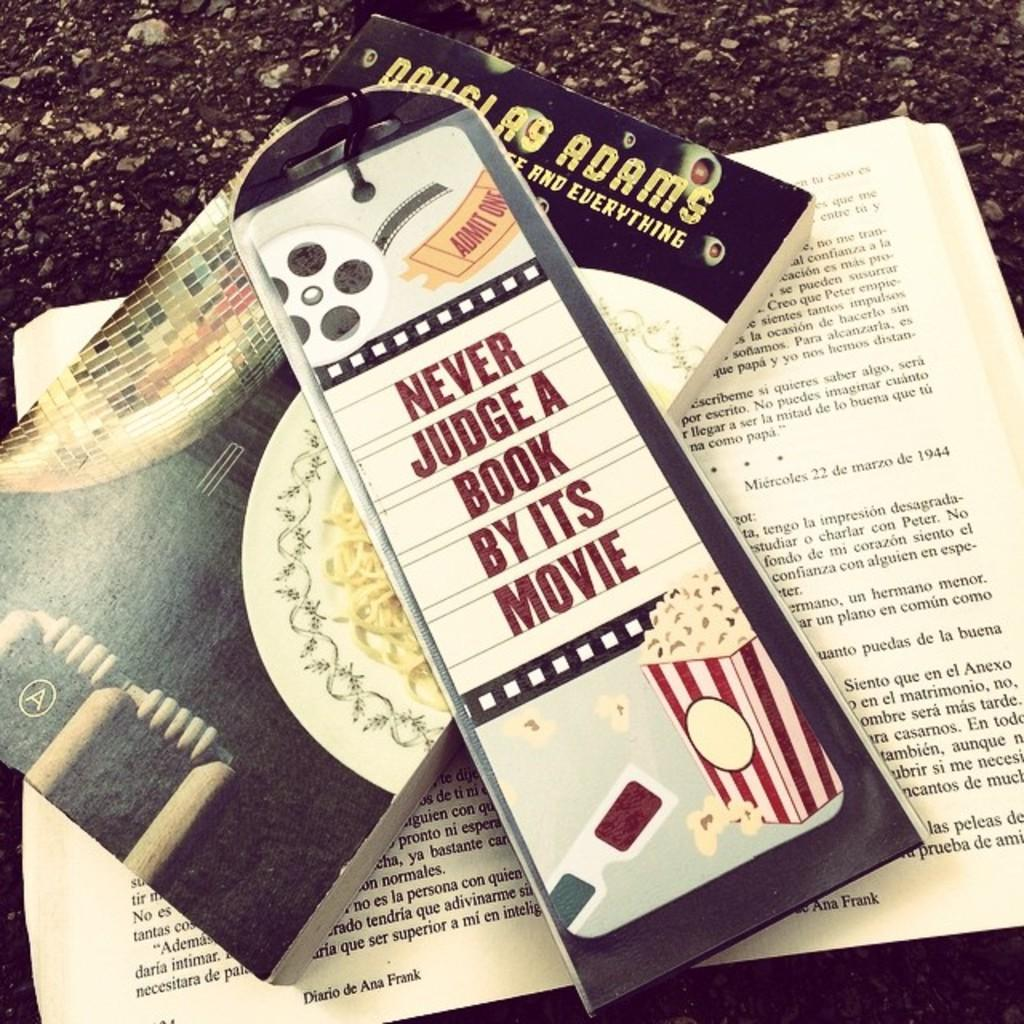<image>
Share a concise interpretation of the image provided. A bookmark sitting on top of a Douglas Adams book that says Never Judge a Book by its Movie 